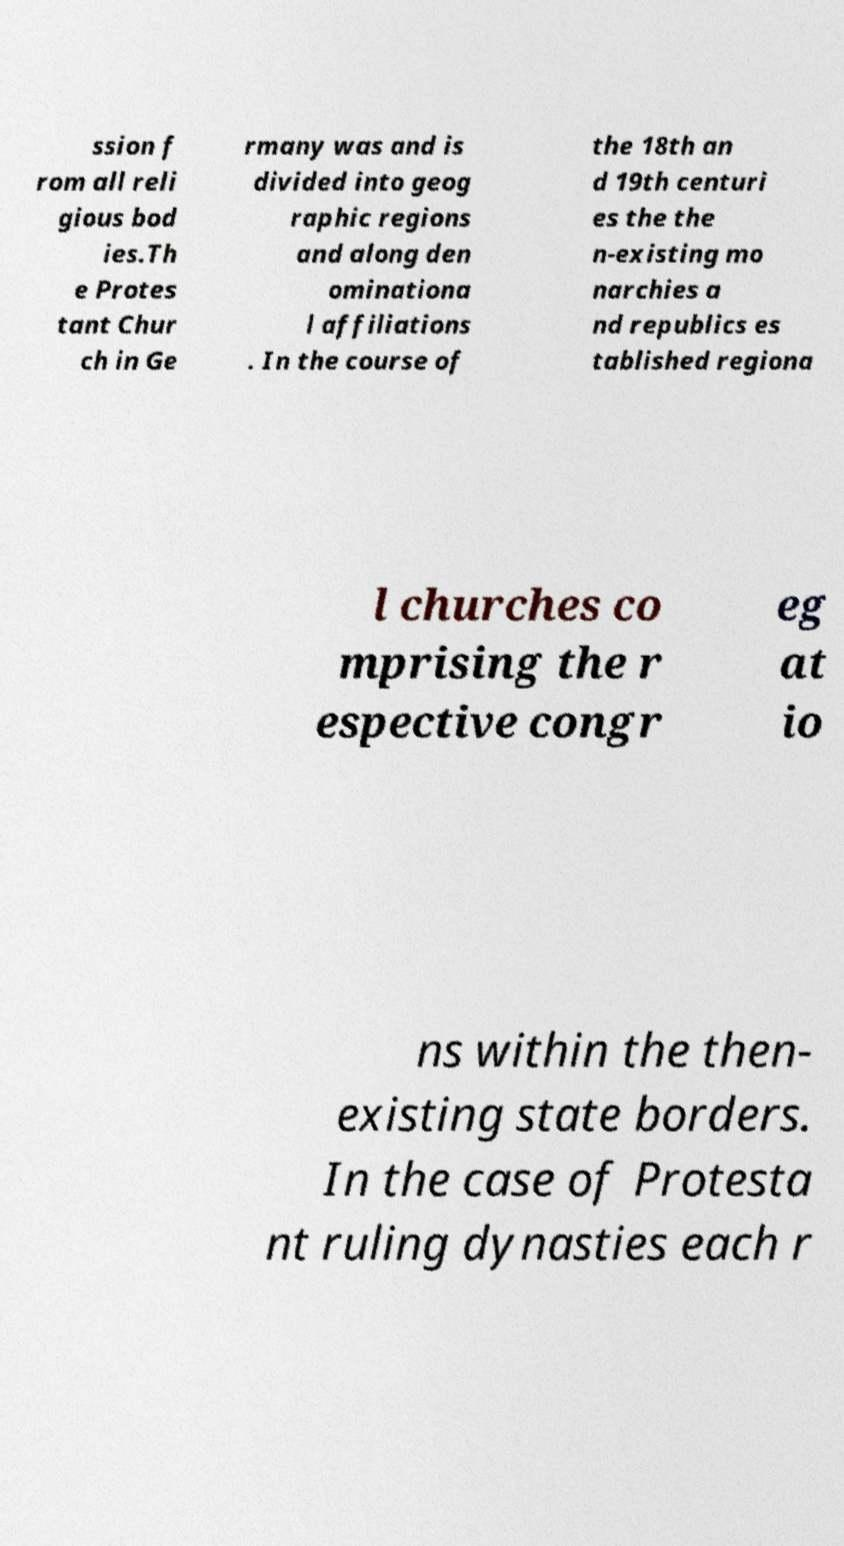There's text embedded in this image that I need extracted. Can you transcribe it verbatim? ssion f rom all reli gious bod ies.Th e Protes tant Chur ch in Ge rmany was and is divided into geog raphic regions and along den ominationa l affiliations . In the course of the 18th an d 19th centuri es the the n-existing mo narchies a nd republics es tablished regiona l churches co mprising the r espective congr eg at io ns within the then- existing state borders. In the case of Protesta nt ruling dynasties each r 